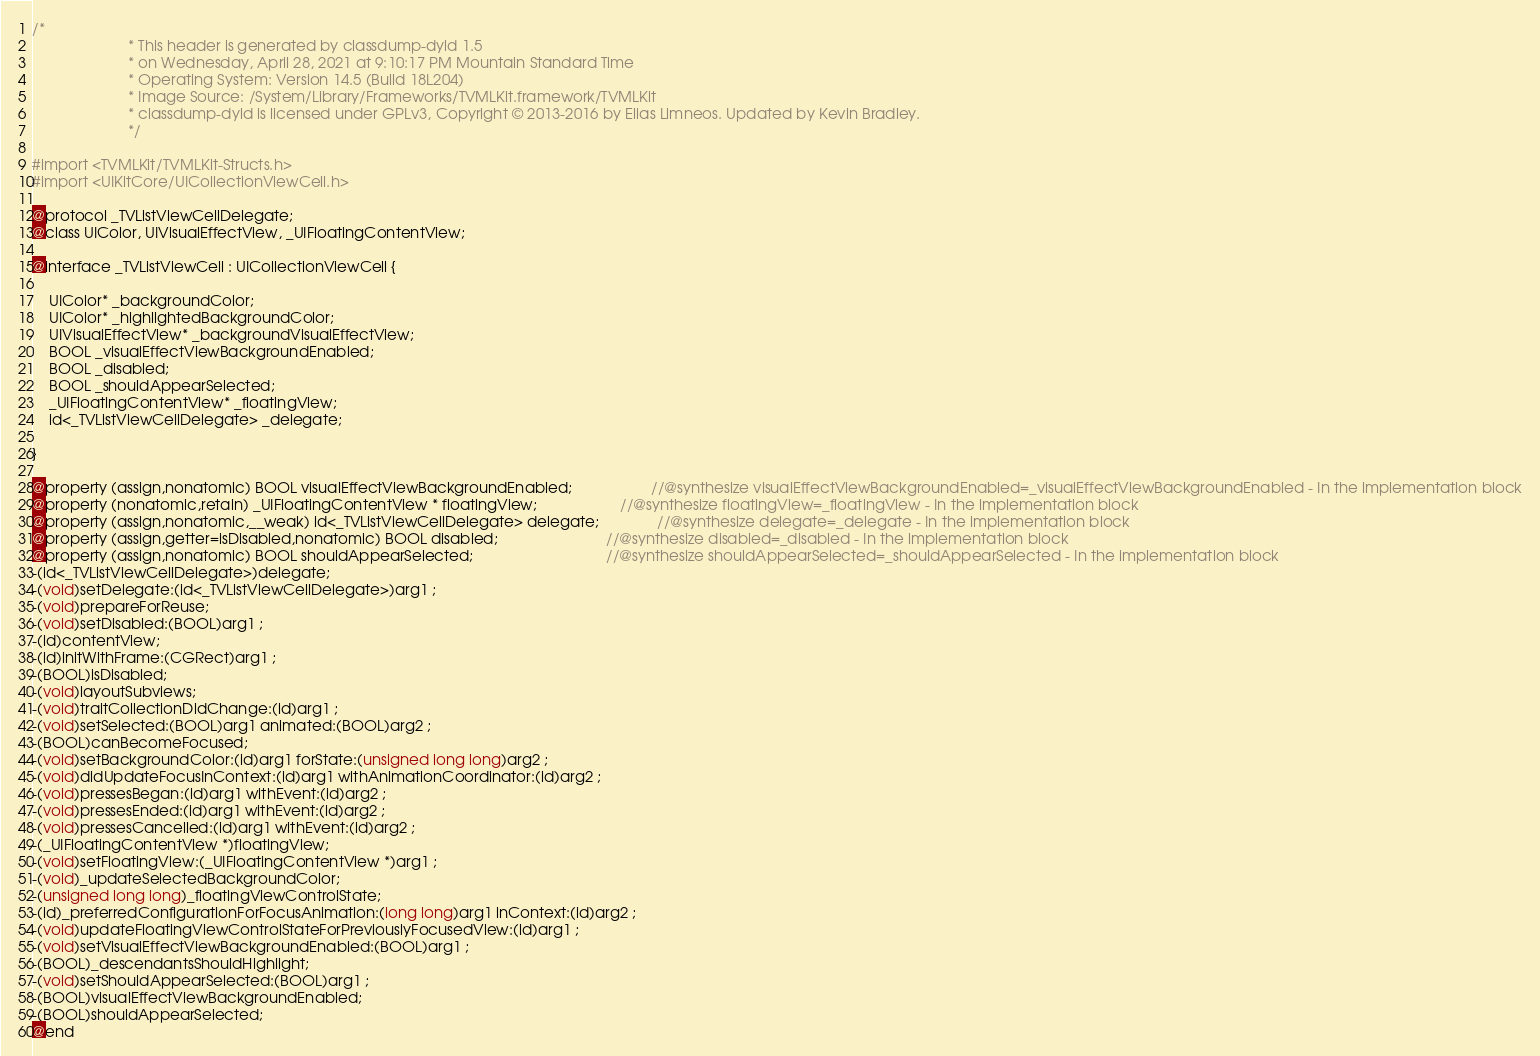<code> <loc_0><loc_0><loc_500><loc_500><_C_>/*
                       * This header is generated by classdump-dyld 1.5
                       * on Wednesday, April 28, 2021 at 9:10:17 PM Mountain Standard Time
                       * Operating System: Version 14.5 (Build 18L204)
                       * Image Source: /System/Library/Frameworks/TVMLKit.framework/TVMLKit
                       * classdump-dyld is licensed under GPLv3, Copyright © 2013-2016 by Elias Limneos. Updated by Kevin Bradley.
                       */

#import <TVMLKit/TVMLKit-Structs.h>
#import <UIKitCore/UICollectionViewCell.h>

@protocol _TVListViewCellDelegate;
@class UIColor, UIVisualEffectView, _UIFloatingContentView;

@interface _TVListViewCell : UICollectionViewCell {

	UIColor* _backgroundColor;
	UIColor* _highlightedBackgroundColor;
	UIVisualEffectView* _backgroundVisualEffectView;
	BOOL _visualEffectViewBackgroundEnabled;
	BOOL _disabled;
	BOOL _shouldAppearSelected;
	_UIFloatingContentView* _floatingView;
	id<_TVListViewCellDelegate> _delegate;

}

@property (assign,nonatomic) BOOL visualEffectViewBackgroundEnabled;                   //@synthesize visualEffectViewBackgroundEnabled=_visualEffectViewBackgroundEnabled - In the implementation block
@property (nonatomic,retain) _UIFloatingContentView * floatingView;                    //@synthesize floatingView=_floatingView - In the implementation block
@property (assign,nonatomic,__weak) id<_TVListViewCellDelegate> delegate;              //@synthesize delegate=_delegate - In the implementation block
@property (assign,getter=isDisabled,nonatomic) BOOL disabled;                          //@synthesize disabled=_disabled - In the implementation block
@property (assign,nonatomic) BOOL shouldAppearSelected;                                //@synthesize shouldAppearSelected=_shouldAppearSelected - In the implementation block
-(id<_TVListViewCellDelegate>)delegate;
-(void)setDelegate:(id<_TVListViewCellDelegate>)arg1 ;
-(void)prepareForReuse;
-(void)setDisabled:(BOOL)arg1 ;
-(id)contentView;
-(id)initWithFrame:(CGRect)arg1 ;
-(BOOL)isDisabled;
-(void)layoutSubviews;
-(void)traitCollectionDidChange:(id)arg1 ;
-(void)setSelected:(BOOL)arg1 animated:(BOOL)arg2 ;
-(BOOL)canBecomeFocused;
-(void)setBackgroundColor:(id)arg1 forState:(unsigned long long)arg2 ;
-(void)didUpdateFocusInContext:(id)arg1 withAnimationCoordinator:(id)arg2 ;
-(void)pressesBegan:(id)arg1 withEvent:(id)arg2 ;
-(void)pressesEnded:(id)arg1 withEvent:(id)arg2 ;
-(void)pressesCancelled:(id)arg1 withEvent:(id)arg2 ;
-(_UIFloatingContentView *)floatingView;
-(void)setFloatingView:(_UIFloatingContentView *)arg1 ;
-(void)_updateSelectedBackgroundColor;
-(unsigned long long)_floatingViewControlState;
-(id)_preferredConfigurationForFocusAnimation:(long long)arg1 inContext:(id)arg2 ;
-(void)updateFloatingViewControlStateForPreviouslyFocusedView:(id)arg1 ;
-(void)setVisualEffectViewBackgroundEnabled:(BOOL)arg1 ;
-(BOOL)_descendantsShouldHighlight;
-(void)setShouldAppearSelected:(BOOL)arg1 ;
-(BOOL)visualEffectViewBackgroundEnabled;
-(BOOL)shouldAppearSelected;
@end

</code> 